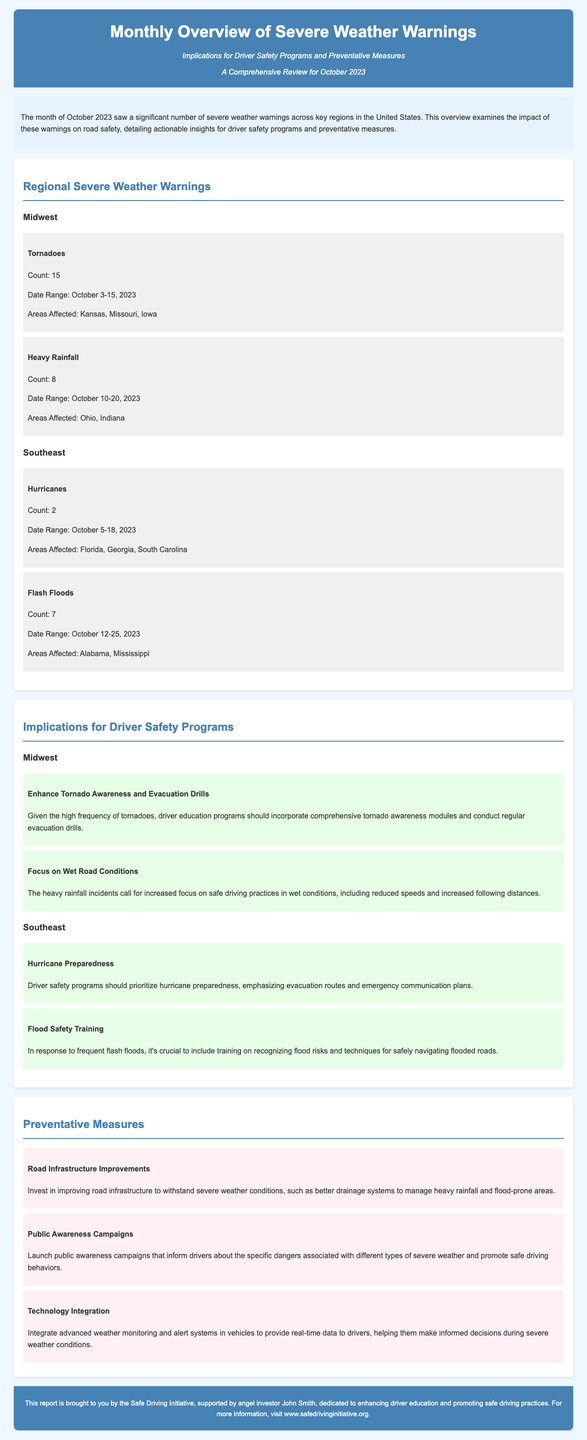What was the total number of tornadoes reported in October 2023? The document states that there were 15 tornadoes reported in the Midwest region during October 2023.
Answer: 15 Which regions were affected by hurricanes in October 2023? The document mentions that Florida, Georgia, and South Carolina were the areas affected by hurricanes.
Answer: Florida, Georgia, South Carolina What is one recommendation for driver safety programs in the Midwest? The document recommends enhancing tornado awareness and evacuation drills due to the high frequency of tornadoes in the Midwest.
Answer: Enhance Tornado Awareness and Evacuation Drills What caused the recommendation to focus on wet road conditions? The recommendation to focus on wet road conditions was prompted by the 8 incidents of heavy rainfall that occurred in the Midwest during October 2023.
Answer: Heavy Rainfall How many flash floods were reported in October 2023? The document states that there were 7 flash floods reported in the Southeast region.
Answer: 7 What is a suggested preventative measure related to road infrastructure? One suggested preventative measure is to improve road infrastructure to withstand severe weather conditions.
Answer: Road Infrastructure Improvements What type of campaigns does the document recommend launching? The document recommends launching public awareness campaigns to inform drivers about dangers associated with severe weather.
Answer: Public Awareness Campaigns 